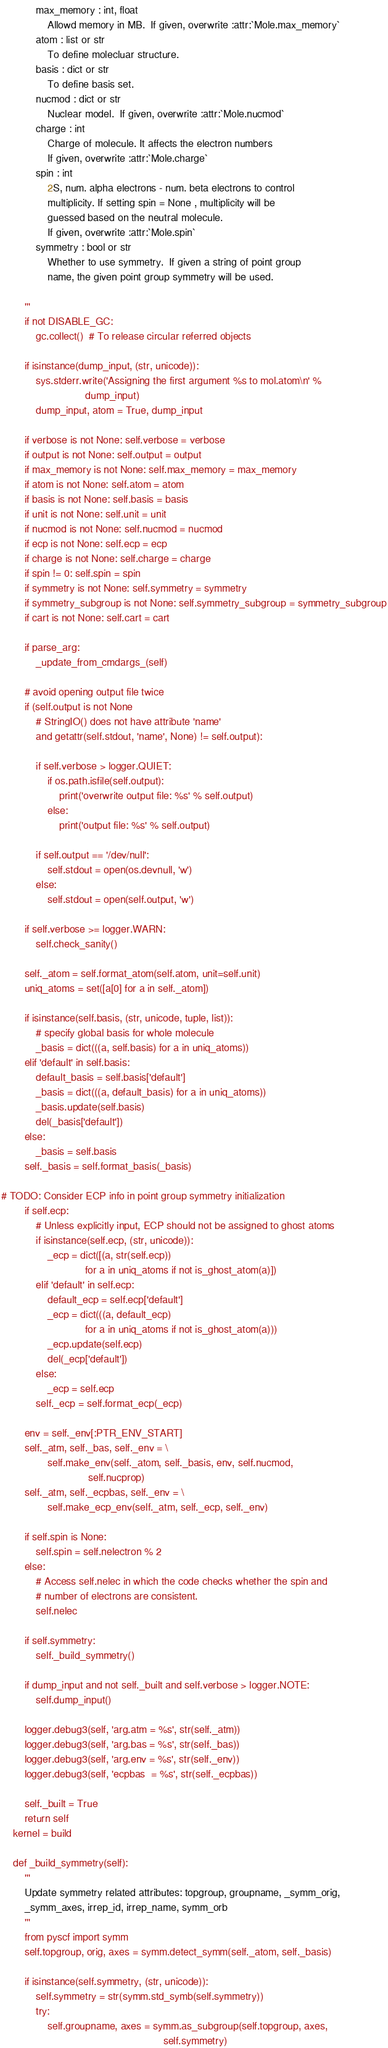Convert code to text. <code><loc_0><loc_0><loc_500><loc_500><_Python_>            max_memory : int, float
                Allowd memory in MB.  If given, overwrite :attr:`Mole.max_memory`
            atom : list or str
                To define molecluar structure.
            basis : dict or str
                To define basis set.
            nucmod : dict or str
                Nuclear model.  If given, overwrite :attr:`Mole.nucmod`
            charge : int
                Charge of molecule. It affects the electron numbers
                If given, overwrite :attr:`Mole.charge`
            spin : int
                2S, num. alpha electrons - num. beta electrons to control
                multiplicity. If setting spin = None , multiplicity will be
                guessed based on the neutral molecule.
                If given, overwrite :attr:`Mole.spin`
            symmetry : bool or str
                Whether to use symmetry.  If given a string of point group
                name, the given point group symmetry will be used.

        '''
        if not DISABLE_GC:
            gc.collect()  # To release circular referred objects

        if isinstance(dump_input, (str, unicode)):
            sys.stderr.write('Assigning the first argument %s to mol.atom\n' %
                             dump_input)
            dump_input, atom = True, dump_input

        if verbose is not None: self.verbose = verbose
        if output is not None: self.output = output
        if max_memory is not None: self.max_memory = max_memory
        if atom is not None: self.atom = atom
        if basis is not None: self.basis = basis
        if unit is not None: self.unit = unit
        if nucmod is not None: self.nucmod = nucmod
        if ecp is not None: self.ecp = ecp
        if charge is not None: self.charge = charge
        if spin != 0: self.spin = spin
        if symmetry is not None: self.symmetry = symmetry
        if symmetry_subgroup is not None: self.symmetry_subgroup = symmetry_subgroup
        if cart is not None: self.cart = cart

        if parse_arg:
            _update_from_cmdargs_(self)

        # avoid opening output file twice
        if (self.output is not None
            # StringIO() does not have attribute 'name'
            and getattr(self.stdout, 'name', None) != self.output):

            if self.verbose > logger.QUIET:
                if os.path.isfile(self.output):
                    print('overwrite output file: %s' % self.output)
                else:
                    print('output file: %s' % self.output)

            if self.output == '/dev/null':
                self.stdout = open(os.devnull, 'w')
            else:
                self.stdout = open(self.output, 'w')

        if self.verbose >= logger.WARN:
            self.check_sanity()

        self._atom = self.format_atom(self.atom, unit=self.unit)
        uniq_atoms = set([a[0] for a in self._atom])

        if isinstance(self.basis, (str, unicode, tuple, list)):
            # specify global basis for whole molecule
            _basis = dict(((a, self.basis) for a in uniq_atoms))
        elif 'default' in self.basis:
            default_basis = self.basis['default']
            _basis = dict(((a, default_basis) for a in uniq_atoms))
            _basis.update(self.basis)
            del(_basis['default'])
        else:
            _basis = self.basis
        self._basis = self.format_basis(_basis)

# TODO: Consider ECP info in point group symmetry initialization
        if self.ecp:
            # Unless explicitly input, ECP should not be assigned to ghost atoms
            if isinstance(self.ecp, (str, unicode)):
                _ecp = dict([(a, str(self.ecp))
                             for a in uniq_atoms if not is_ghost_atom(a)])
            elif 'default' in self.ecp:
                default_ecp = self.ecp['default']
                _ecp = dict(((a, default_ecp)
                             for a in uniq_atoms if not is_ghost_atom(a)))
                _ecp.update(self.ecp)
                del(_ecp['default'])
            else:
                _ecp = self.ecp
            self._ecp = self.format_ecp(_ecp)

        env = self._env[:PTR_ENV_START]
        self._atm, self._bas, self._env = \
                self.make_env(self._atom, self._basis, env, self.nucmod,
                              self.nucprop)
        self._atm, self._ecpbas, self._env = \
                self.make_ecp_env(self._atm, self._ecp, self._env)

        if self.spin is None:
            self.spin = self.nelectron % 2
        else:
            # Access self.nelec in which the code checks whether the spin and
            # number of electrons are consistent.
            self.nelec

        if self.symmetry:
            self._build_symmetry()

        if dump_input and not self._built and self.verbose > logger.NOTE:
            self.dump_input()

        logger.debug3(self, 'arg.atm = %s', str(self._atm))
        logger.debug3(self, 'arg.bas = %s', str(self._bas))
        logger.debug3(self, 'arg.env = %s', str(self._env))
        logger.debug3(self, 'ecpbas  = %s', str(self._ecpbas))

        self._built = True
        return self
    kernel = build

    def _build_symmetry(self):
        '''
        Update symmetry related attributes: topgroup, groupname, _symm_orig,
        _symm_axes, irrep_id, irrep_name, symm_orb
        '''
        from pyscf import symm
        self.topgroup, orig, axes = symm.detect_symm(self._atom, self._basis)

        if isinstance(self.symmetry, (str, unicode)):
            self.symmetry = str(symm.std_symb(self.symmetry))
            try:
                self.groupname, axes = symm.as_subgroup(self.topgroup, axes,
                                                        self.symmetry)</code> 